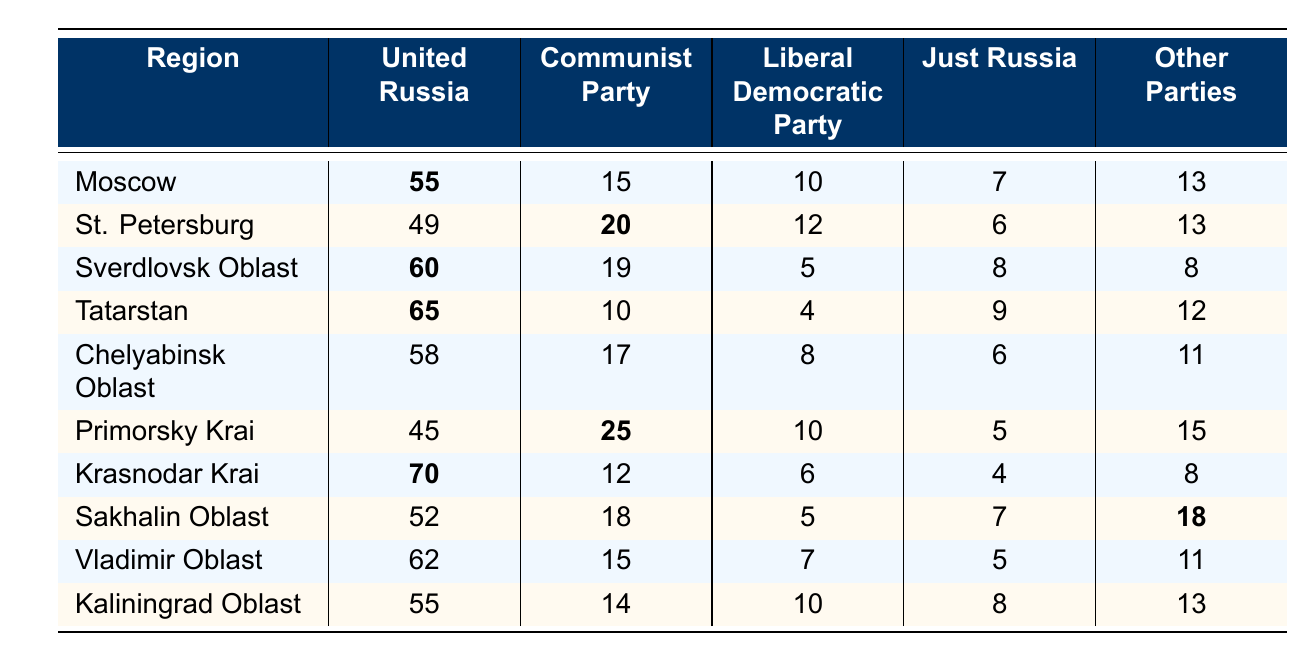What region has the highest representation from the United Russia party? By looking at the values for United Russia in the table, the highest value is 70 in Krasnodar Krai, which is greater than any other region.
Answer: Krasnodar Krai What is the total representation of the Other Parties in Tatarstan? The Other Parties representation in Tatarstan is shown directly in the table as 12.
Answer: 12 Which party has the lowest representation in Sverdlovsk Oblast? The Liberal Democratic Party has the lowest representation in Sverdlovsk Oblast with a value of 5 when compared to the other parties.
Answer: Liberal Democratic Party In which region is the Communist Party represented the most? The highest value for the Communist Party is 25, which occurs in Primorsky Krai according to the table.
Answer: Primorsky Krai What is the average representation from the Just Russia party across all regions? To find the average, add up all the values for Just Russia: 7 + 6 + 8 + 9 + 6 + 5 + 4 + 7 + 5 + 8 = 56. There are 10 regions, so divide 56 by 10, resulting in an average of 5.6.
Answer: 5.6 True or False: The representation of the Liberal Democratic Party is greater in Moscow than in St. Petersburg. In the table, Moscow has a value of 10 for the Liberal Democratic Party, while St. Petersburg has a value of 12, making the statement false.
Answer: False How much higher is the representation of the Communist Party in Primorsky Krai compared to Kaliningrad Oblast? The Communist Party has a value of 25 in Primorsky Krai and 14 in Kaliningrad Oblast. The difference is 25 - 14 = 11.
Answer: 11 Which region has the lowest total representation among all parties combined? To find the total representation for each region, sum the values for all parties in each region. The region with the lowest total is Primorsky Krai at 45 + 25 + 10 + 5 + 15 = 100.
Answer: Primorsky Krai If you combine the representation of United Russia and the Communist Party in Tatarstan, what do you get? The values in Tatarstan are United Russia: 65 and Communist Party: 10. Adding these gives 65 + 10 = 75.
Answer: 75 Which region shows the highest representation for Other Parties, and what is this value? By inspecting the table, Sakhalin Oblast shows the highest value for Other Parties, which is 18.
Answer: Sakhalin Oblast, 18 